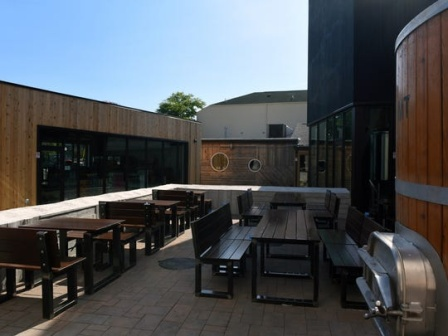Explain the visual content of the image in great detail. The image portrays an inviting scene at an outdoor brewery patio. The floor is crafted from wooden planks that gleam under the warm rays of the sun. Shadows stretch across the surface, adding a dynamic feel to the scene. Several sturdy wooden tables and benches are strategically placed across the space, providing ample seating for guests looking to enjoy their beverages in a pleasant open-air setting.

On the right side, two large stainless-steel fermenters are prominently positioned, underscoring the brewing operations nearby. Their sleek metallic texture provides a striking contrast to the wooden elements of the patio. A neatly constructed wooden fence encloses the patio area, creating a sense of privacy and coziness for the patrons.

Beyond the confines of the patio, a sizable dark building stands. This building’s somber tones juxtapose pleasantly with the vibrant outdoor setting and the clear blue sky above. The sun casts an even, warm light over the entire area, bringing out the rich textures of wood and metal alike. This idyllic snapshot captures the serene yet lively atmosphere of a sunny day at the brewery patio. 